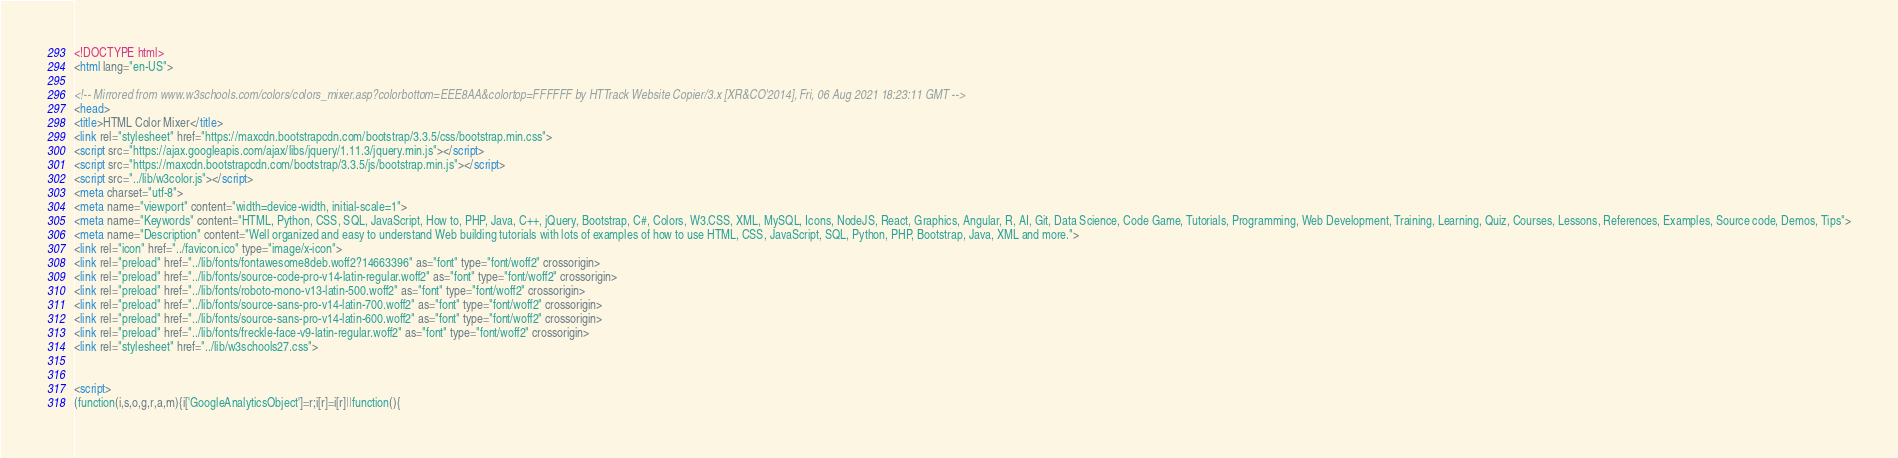<code> <loc_0><loc_0><loc_500><loc_500><_HTML_><!DOCTYPE html>
<html lang="en-US">

<!-- Mirrored from www.w3schools.com/colors/colors_mixer.asp?colorbottom=EEE8AA&colortop=FFFFFF by HTTrack Website Copier/3.x [XR&CO'2014], Fri, 06 Aug 2021 18:23:11 GMT -->
<head>
<title>HTML Color Mixer</title>
<link rel="stylesheet" href="https://maxcdn.bootstrapcdn.com/bootstrap/3.3.5/css/bootstrap.min.css">
<script src="https://ajax.googleapis.com/ajax/libs/jquery/1.11.3/jquery.min.js"></script>
<script src="https://maxcdn.bootstrapcdn.com/bootstrap/3.3.5/js/bootstrap.min.js"></script>
<script src="../lib/w3color.js"></script>
<meta charset="utf-8">
<meta name="viewport" content="width=device-width, initial-scale=1">
<meta name="Keywords" content="HTML, Python, CSS, SQL, JavaScript, How to, PHP, Java, C++, jQuery, Bootstrap, C#, Colors, W3.CSS, XML, MySQL, Icons, NodeJS, React, Graphics, Angular, R, AI, Git, Data Science, Code Game, Tutorials, Programming, Web Development, Training, Learning, Quiz, Courses, Lessons, References, Examples, Source code, Demos, Tips">
<meta name="Description" content="Well organized and easy to understand Web building tutorials with lots of examples of how to use HTML, CSS, JavaScript, SQL, Python, PHP, Bootstrap, Java, XML and more.">
<link rel="icon" href="../favicon.ico" type="image/x-icon">
<link rel="preload" href="../lib/fonts/fontawesome8deb.woff2?14663396" as="font" type="font/woff2" crossorigin> 
<link rel="preload" href="../lib/fonts/source-code-pro-v14-latin-regular.woff2" as="font" type="font/woff2" crossorigin> 
<link rel="preload" href="../lib/fonts/roboto-mono-v13-latin-500.woff2" as="font" type="font/woff2" crossorigin> 
<link rel="preload" href="../lib/fonts/source-sans-pro-v14-latin-700.woff2" as="font" type="font/woff2" crossorigin> 
<link rel="preload" href="../lib/fonts/source-sans-pro-v14-latin-600.woff2" as="font" type="font/woff2" crossorigin> 
<link rel="preload" href="../lib/fonts/freckle-face-v9-latin-regular.woff2" as="font" type="font/woff2" crossorigin> 
<link rel="stylesheet" href="../lib/w3schools27.css">


<script>
(function(i,s,o,g,r,a,m){i['GoogleAnalyticsObject']=r;i[r]=i[r]||function(){</code> 